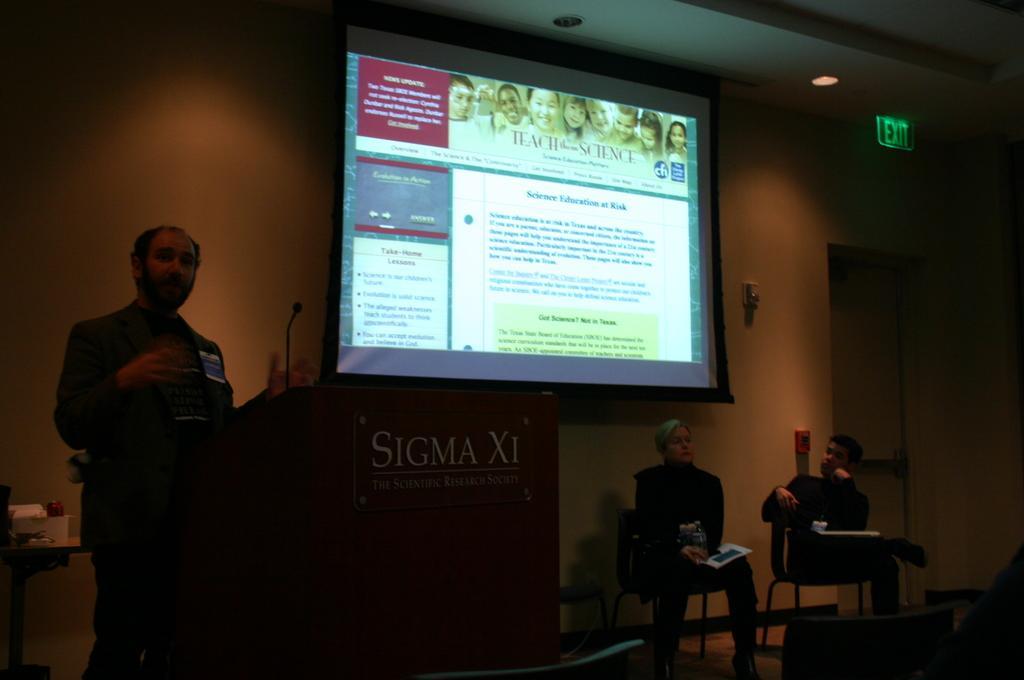In one or two sentences, can you explain what this image depicts? In the image we can see a man standing and two of them are sitting, they are wearing clothes. Here we can see the podium, microphone and projected screen. Here we can see instruction board, wall and the door. 